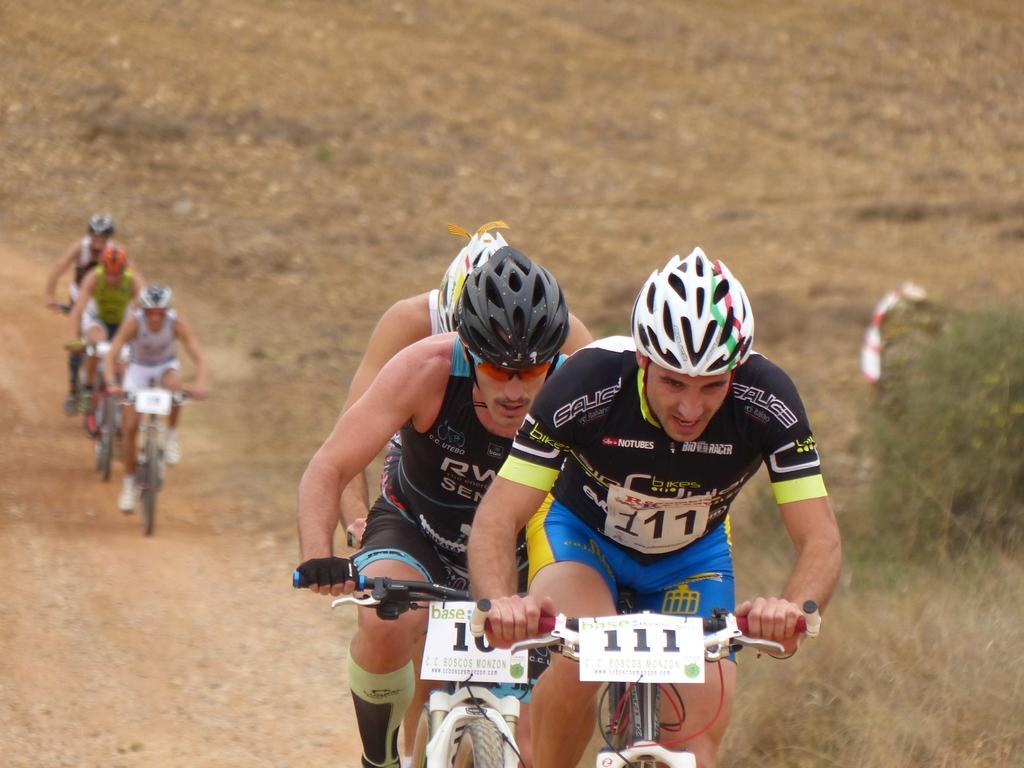How would you summarize this image in a sentence or two? In this image we can see men sitting on the bicycles, ground and grass. 